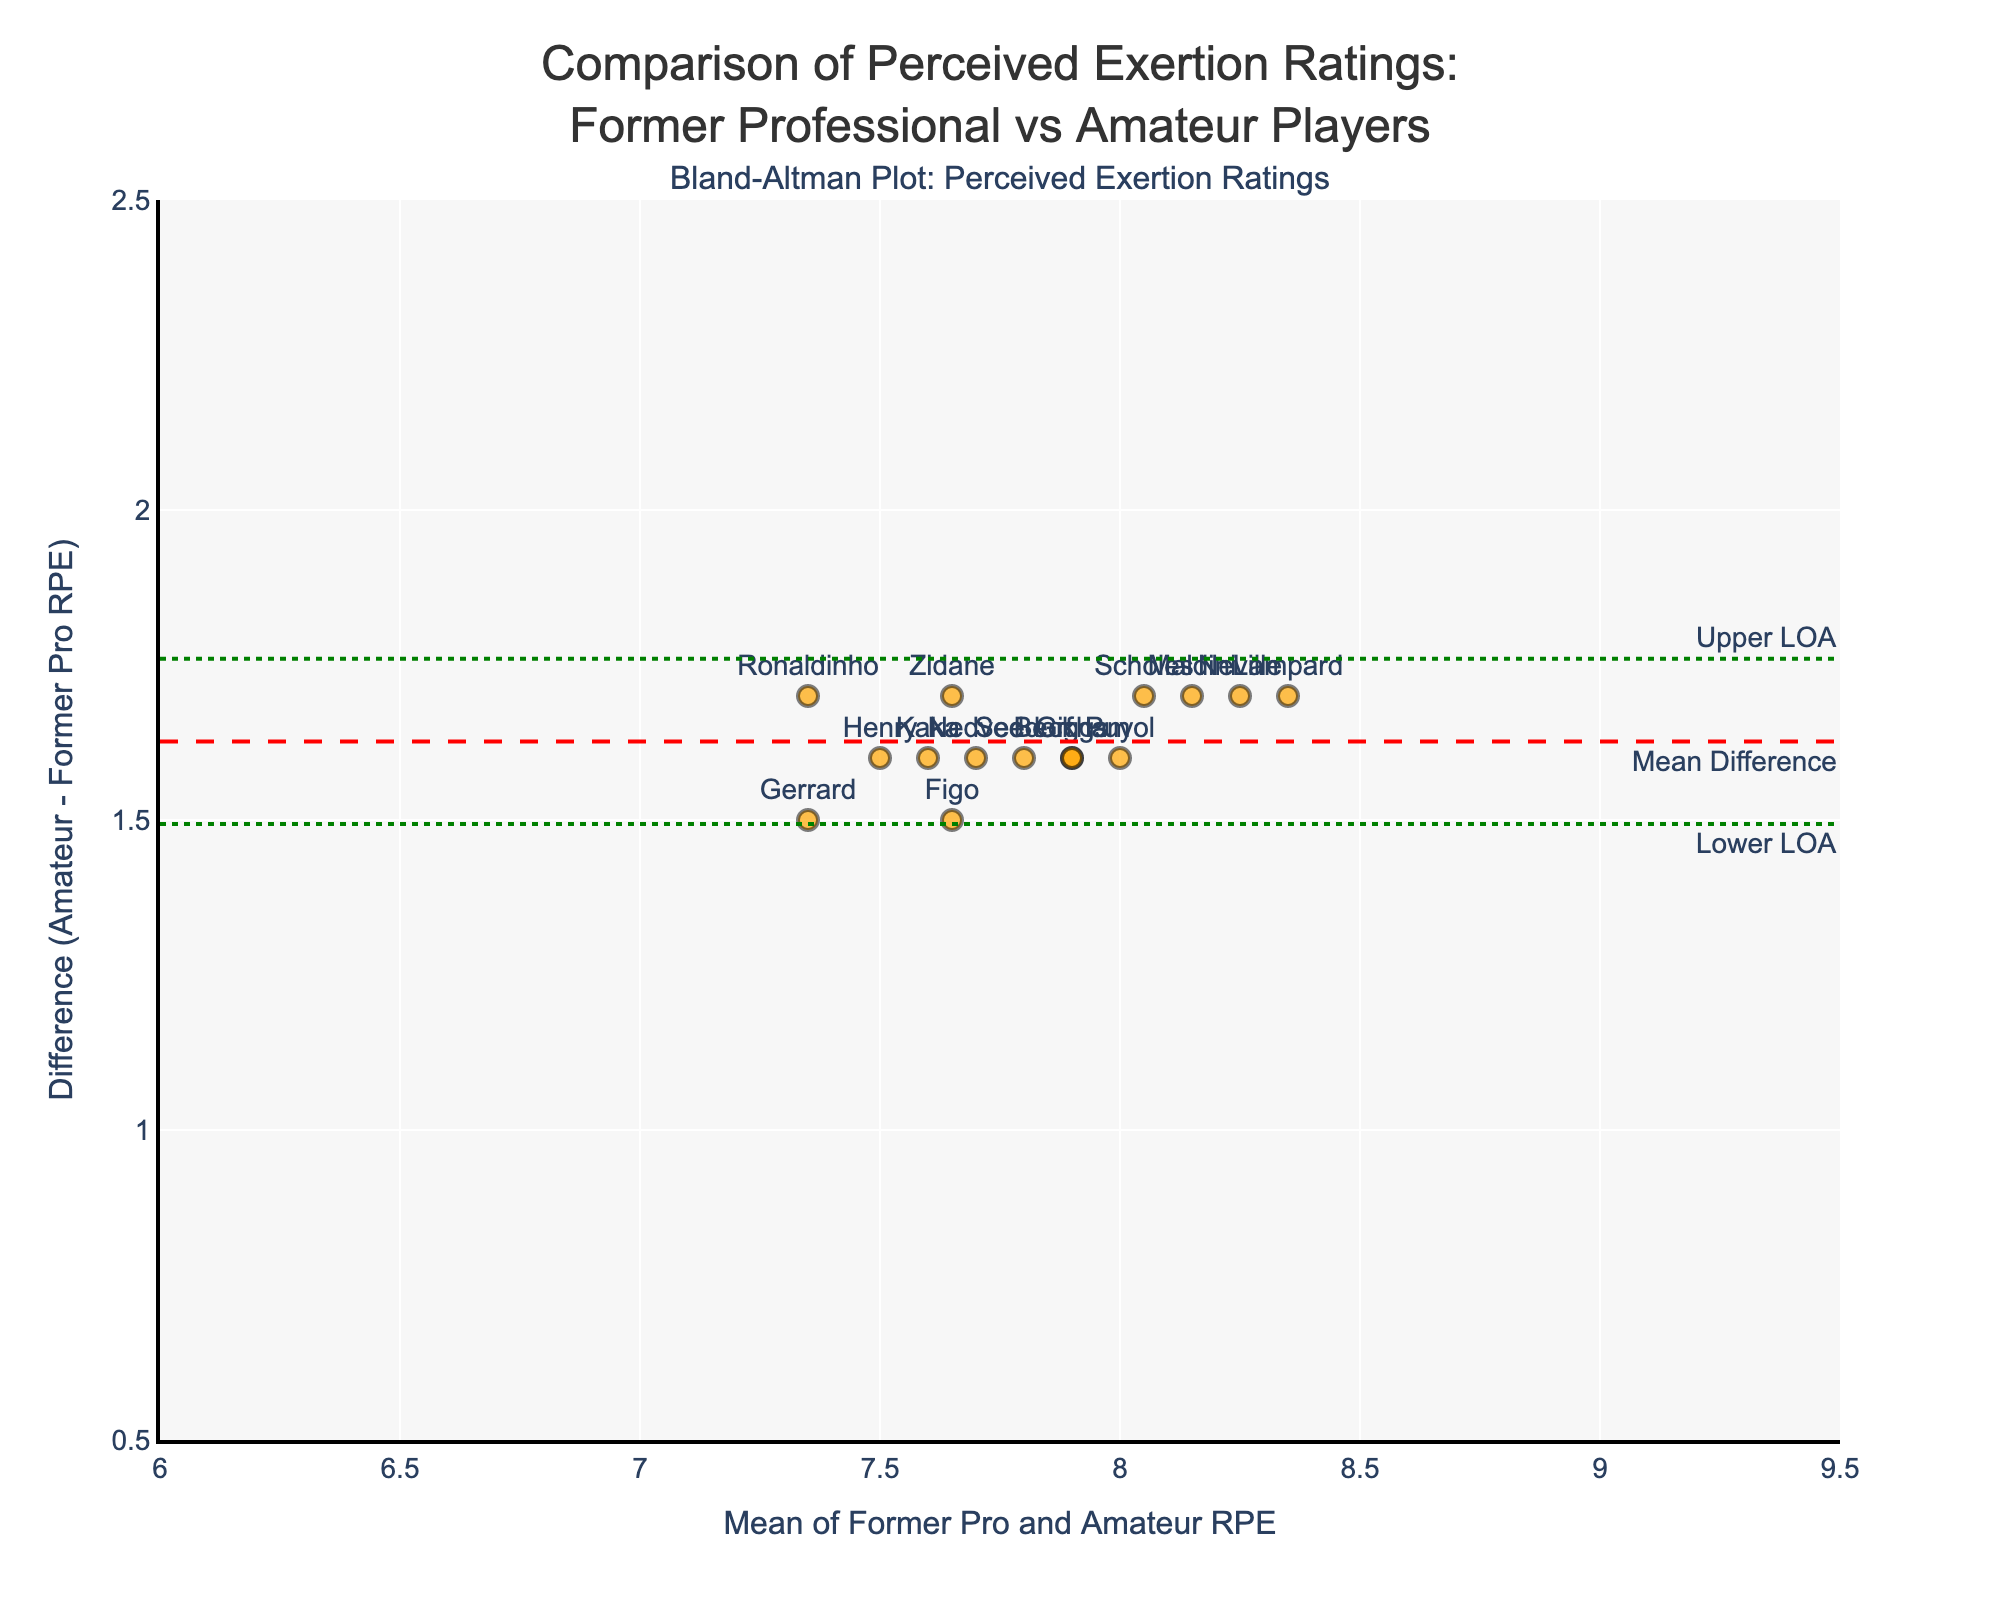What is the title of the plot? The title of the plot is displayed at the top, which reads 'Comparison of Perceived Exertion Ratings: Former Professional vs Amateur Players'.
Answer: Comparison of Perceived Exertion Ratings: Former Professional vs Amateur Players What does the horizontal axis represent? The horizontal axis represents the mean of perceived exertion ratings from former professional players and amateur players. It is labeled as 'Mean of Former Pro and Amateur RPE'.
Answer: Mean of Former Pro and Amateur RPE What are the units used in the vertical axis? The vertical axis measures the difference between the perceived exertion ratings of amateur players and former professional players. It is labeled as 'Difference (Amateur - Former Pro RPE)'.
Answer: Difference (Amateur - Former Pro RPE) How many players' exertion ratings are plotted? By counting the labeled points on the plot, we can see that there are 15 players' exertion ratings being plotted. Each point represents one player.
Answer: 15 Who has the largest difference in exertion ratings? By observing the vertical placement of data points, Neville has the largest difference in exertion ratings between amateur and former pro players.
Answer: Neville What is the range of the horizontal axis? The horizontal axis ranges from 6 to 9.5, as observed on the plot.
Answer: 6 to 9.5 What does the dashed red line represent? The dashed red line represents the mean difference between the perceived exertion ratings of amateur players and former professional players.
Answer: Mean difference What does the dotted green line above the mean difference represent? The dotted green line above the mean difference line represents the upper limit of agreement (Upper LOA) between the perceived exertion ratings of amateur players and former professional players.
Answer: Upper LOA What is the mean difference in exertion ratings between amateur and former professional players? The mean difference is represented by the horizontal dashed red line on the plot. Reading the annotation or value on the vertical axis where this line is positioned provides the mean difference value, roughly around 1.8.
Answer: 1.8 Which player has an exertion rating closest to the mean? By observing the plot, Seedorf's data point is closest to the mean of the former pro and amateur exertion ratings.
Answer: Seedorf 